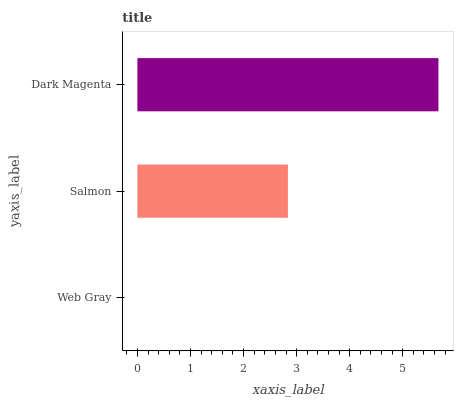Is Web Gray the minimum?
Answer yes or no. Yes. Is Dark Magenta the maximum?
Answer yes or no. Yes. Is Salmon the minimum?
Answer yes or no. No. Is Salmon the maximum?
Answer yes or no. No. Is Salmon greater than Web Gray?
Answer yes or no. Yes. Is Web Gray less than Salmon?
Answer yes or no. Yes. Is Web Gray greater than Salmon?
Answer yes or no. No. Is Salmon less than Web Gray?
Answer yes or no. No. Is Salmon the high median?
Answer yes or no. Yes. Is Salmon the low median?
Answer yes or no. Yes. Is Dark Magenta the high median?
Answer yes or no. No. Is Web Gray the low median?
Answer yes or no. No. 